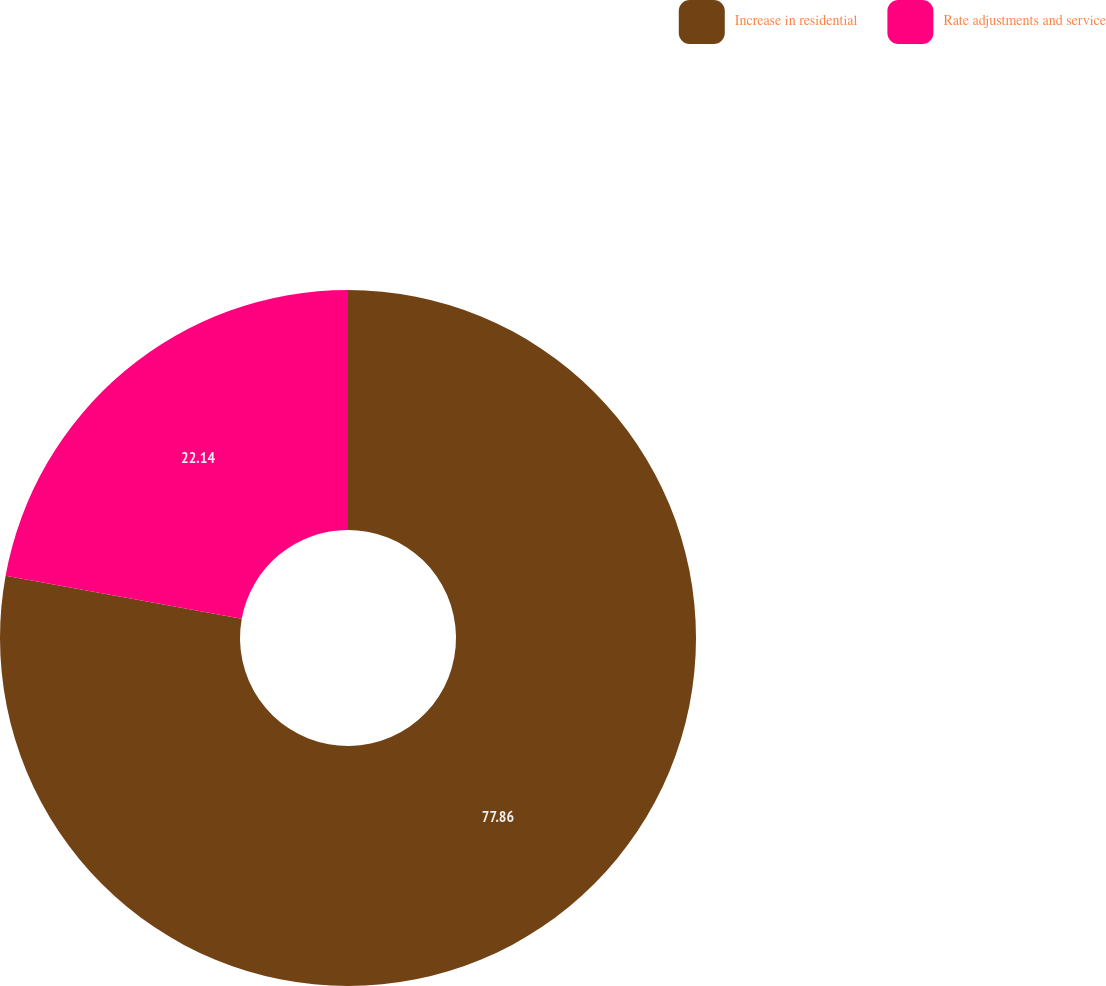Convert chart. <chart><loc_0><loc_0><loc_500><loc_500><pie_chart><fcel>Increase in residential<fcel>Rate adjustments and service<nl><fcel>77.86%<fcel>22.14%<nl></chart> 